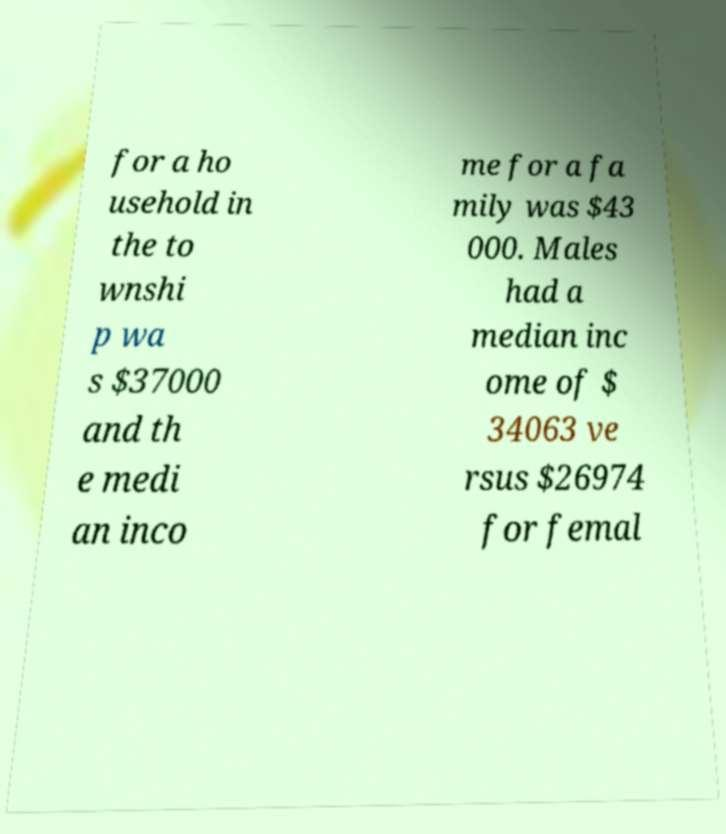Can you read and provide the text displayed in the image?This photo seems to have some interesting text. Can you extract and type it out for me? for a ho usehold in the to wnshi p wa s $37000 and th e medi an inco me for a fa mily was $43 000. Males had a median inc ome of $ 34063 ve rsus $26974 for femal 